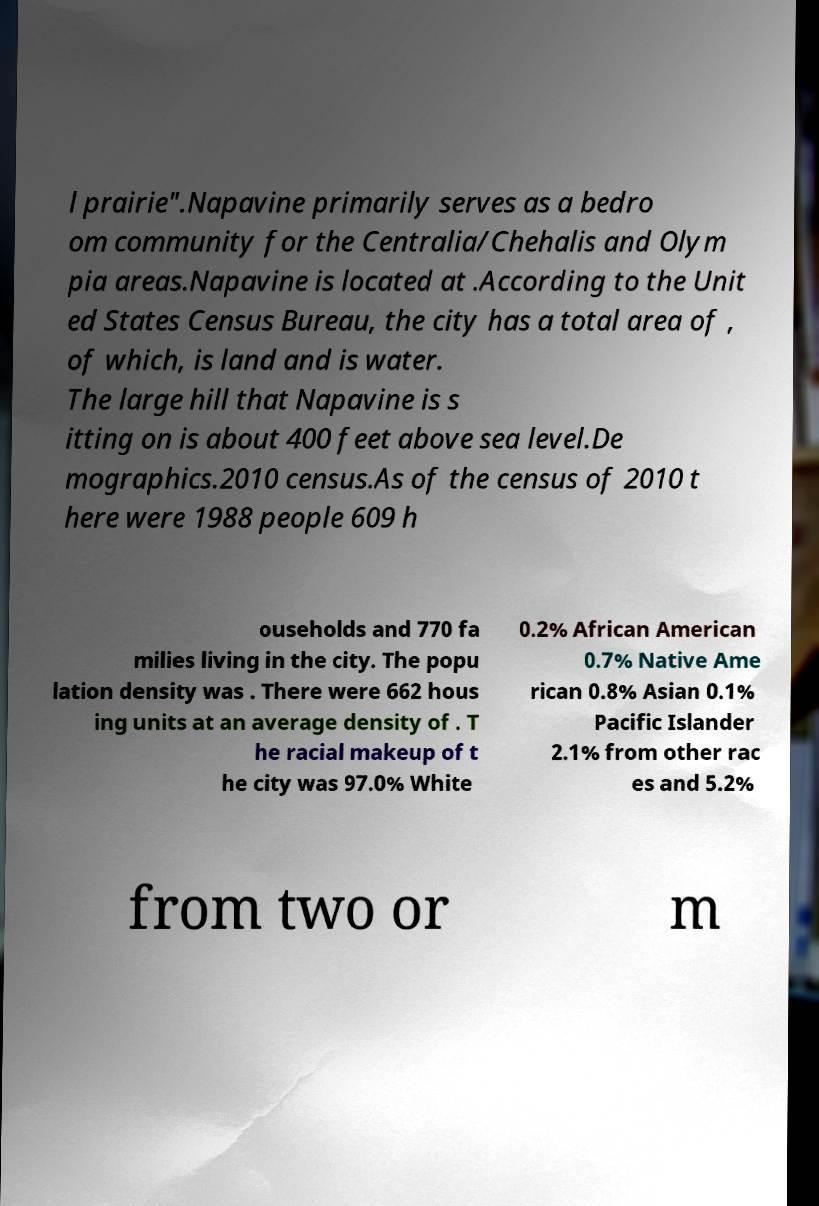Please read and relay the text visible in this image. What does it say? l prairie".Napavine primarily serves as a bedro om community for the Centralia/Chehalis and Olym pia areas.Napavine is located at .According to the Unit ed States Census Bureau, the city has a total area of , of which, is land and is water. The large hill that Napavine is s itting on is about 400 feet above sea level.De mographics.2010 census.As of the census of 2010 t here were 1988 people 609 h ouseholds and 770 fa milies living in the city. The popu lation density was . There were 662 hous ing units at an average density of . T he racial makeup of t he city was 97.0% White 0.2% African American 0.7% Native Ame rican 0.8% Asian 0.1% Pacific Islander 2.1% from other rac es and 5.2% from two or m 